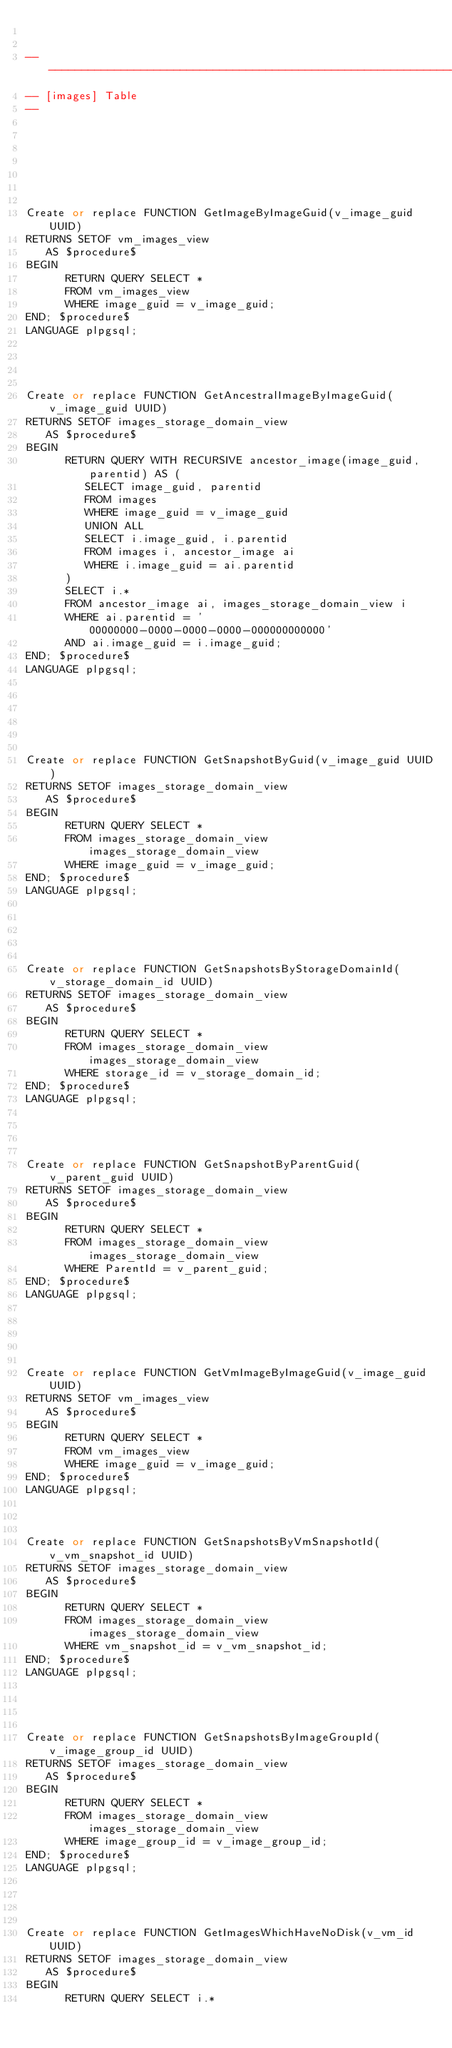Convert code to text. <code><loc_0><loc_0><loc_500><loc_500><_SQL_>

----------------------------------------------------------------
-- [images] Table
--







Create or replace FUNCTION GetImageByImageGuid(v_image_guid UUID)
RETURNS SETOF vm_images_view
   AS $procedure$
BEGIN
      RETURN QUERY SELECT *
      FROM vm_images_view
      WHERE image_guid = v_image_guid;
END; $procedure$
LANGUAGE plpgsql;




Create or replace FUNCTION GetAncestralImageByImageGuid(v_image_guid UUID)
RETURNS SETOF images_storage_domain_view
   AS $procedure$
BEGIN
      RETURN QUERY WITH RECURSIVE ancestor_image(image_guid, parentid) AS (
         SELECT image_guid, parentid
         FROM images
         WHERE image_guid = v_image_guid
         UNION ALL
         SELECT i.image_guid, i.parentid
         FROM images i, ancestor_image ai
         WHERE i.image_guid = ai.parentid
      )
      SELECT i.*
      FROM ancestor_image ai, images_storage_domain_view i
      WHERE ai.parentid = '00000000-0000-0000-0000-000000000000'
      AND ai.image_guid = i.image_guid;
END; $procedure$
LANGUAGE plpgsql;






Create or replace FUNCTION GetSnapshotByGuid(v_image_guid UUID)
RETURNS SETOF images_storage_domain_view
   AS $procedure$
BEGIN
      RETURN QUERY SELECT *
      FROM images_storage_domain_view images_storage_domain_view
      WHERE image_guid = v_image_guid;
END; $procedure$
LANGUAGE plpgsql;





Create or replace FUNCTION GetSnapshotsByStorageDomainId(v_storage_domain_id UUID)
RETURNS SETOF images_storage_domain_view
   AS $procedure$
BEGIN
      RETURN QUERY SELECT *
      FROM images_storage_domain_view images_storage_domain_view
      WHERE storage_id = v_storage_domain_id;
END; $procedure$
LANGUAGE plpgsql;




Create or replace FUNCTION GetSnapshotByParentGuid(v_parent_guid UUID)
RETURNS SETOF images_storage_domain_view
   AS $procedure$
BEGIN
      RETURN QUERY SELECT *
      FROM images_storage_domain_view images_storage_domain_view
      WHERE ParentId = v_parent_guid;
END; $procedure$
LANGUAGE plpgsql;





Create or replace FUNCTION GetVmImageByImageGuid(v_image_guid UUID)
RETURNS SETOF vm_images_view
   AS $procedure$
BEGIN
      RETURN QUERY SELECT *
      FROM vm_images_view
      WHERE image_guid = v_image_guid;
END; $procedure$
LANGUAGE plpgsql;



Create or replace FUNCTION GetSnapshotsByVmSnapshotId(v_vm_snapshot_id UUID)
RETURNS SETOF images_storage_domain_view
   AS $procedure$
BEGIN
      RETURN QUERY SELECT *
      FROM images_storage_domain_view images_storage_domain_view
      WHERE vm_snapshot_id = v_vm_snapshot_id;
END; $procedure$
LANGUAGE plpgsql;




Create or replace FUNCTION GetSnapshotsByImageGroupId(v_image_group_id UUID)
RETURNS SETOF images_storage_domain_view
   AS $procedure$
BEGIN
      RETURN QUERY SELECT *
      FROM images_storage_domain_view images_storage_domain_view
      WHERE image_group_id = v_image_group_id;
END; $procedure$
LANGUAGE plpgsql;




Create or replace FUNCTION GetImagesWhichHaveNoDisk(v_vm_id UUID)
RETURNS SETOF images_storage_domain_view
   AS $procedure$
BEGIN
      RETURN QUERY SELECT i.*</code> 